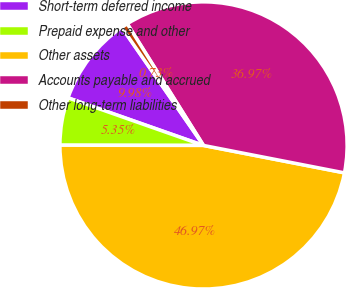Convert chart to OTSL. <chart><loc_0><loc_0><loc_500><loc_500><pie_chart><fcel>Short-term deferred income<fcel>Prepaid expense and other<fcel>Other assets<fcel>Accounts payable and accrued<fcel>Other long-term liabilities<nl><fcel>9.98%<fcel>5.35%<fcel>46.97%<fcel>36.97%<fcel>0.73%<nl></chart> 